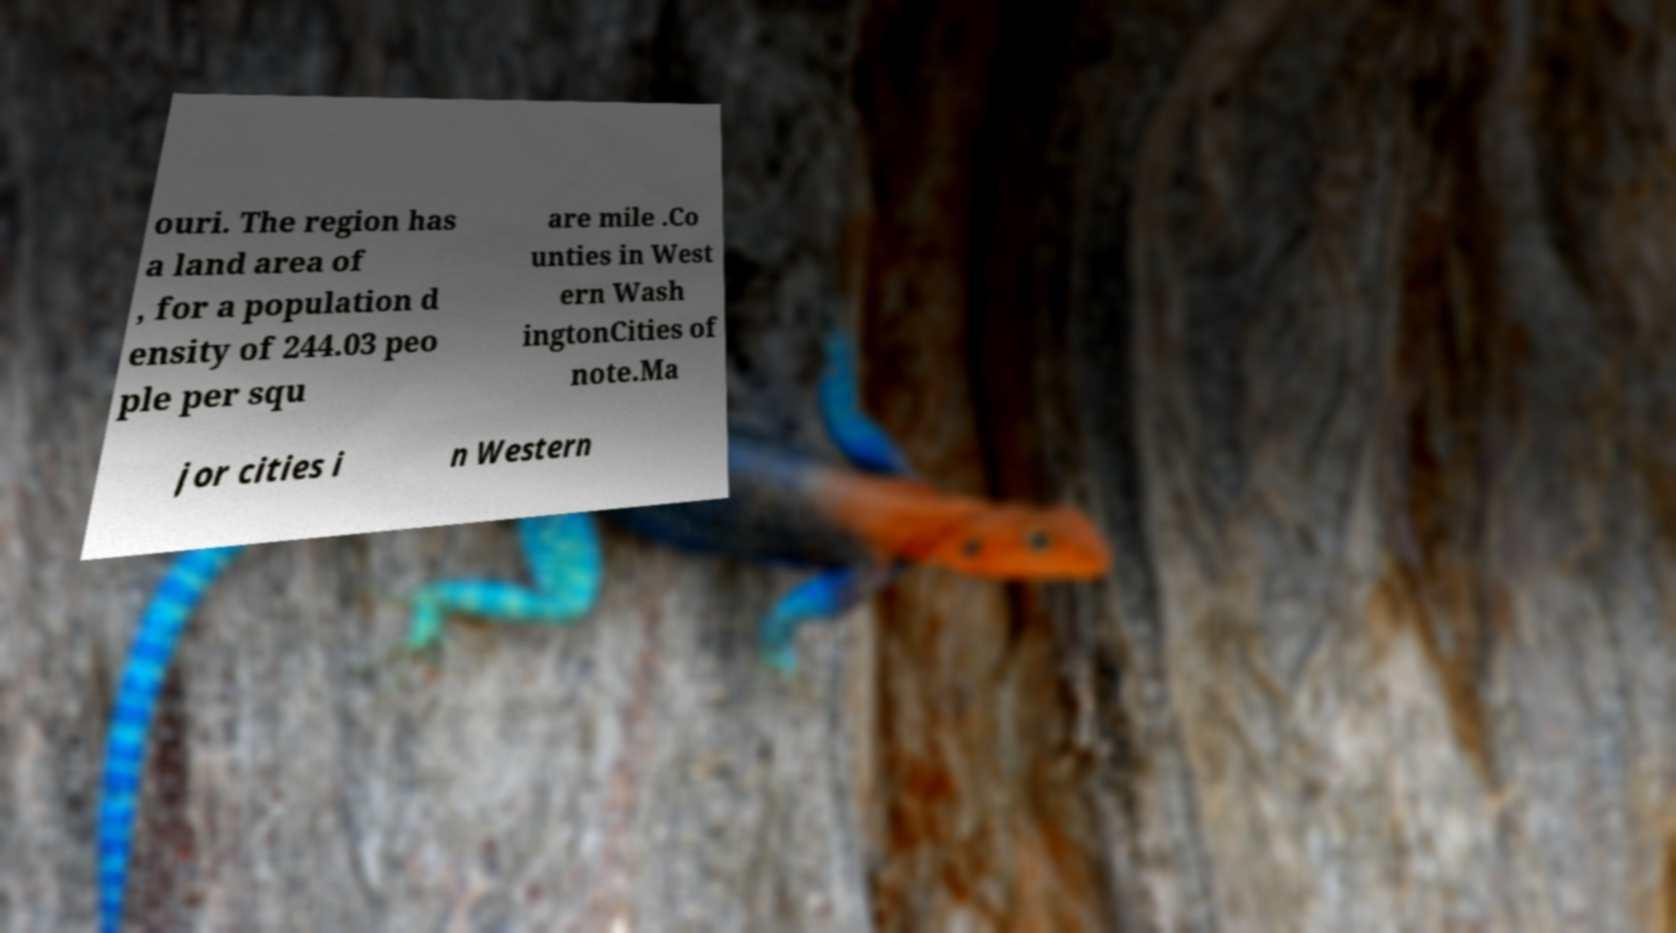What messages or text are displayed in this image? I need them in a readable, typed format. ouri. The region has a land area of , for a population d ensity of 244.03 peo ple per squ are mile .Co unties in West ern Wash ingtonCities of note.Ma jor cities i n Western 